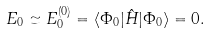Convert formula to latex. <formula><loc_0><loc_0><loc_500><loc_500>E _ { 0 } \simeq E ^ { ( 0 ) } _ { 0 } = \langle \Phi _ { 0 } | \hat { H } | \Phi _ { 0 } \rangle = 0 .</formula> 